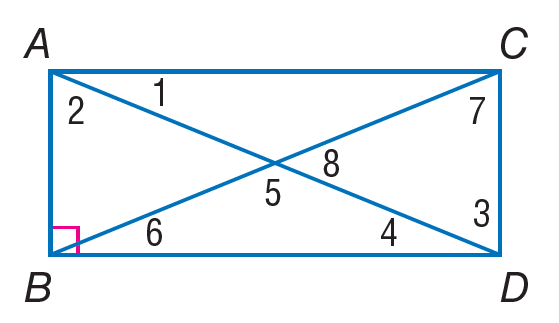Answer the mathemtical geometry problem and directly provide the correct option letter.
Question: Quadrilateral A B D C is a rectangle. Find m \angle 6 if m \angle 1 = 38.
Choices: A: 38 B: 52 C: 108 D: 132 A 